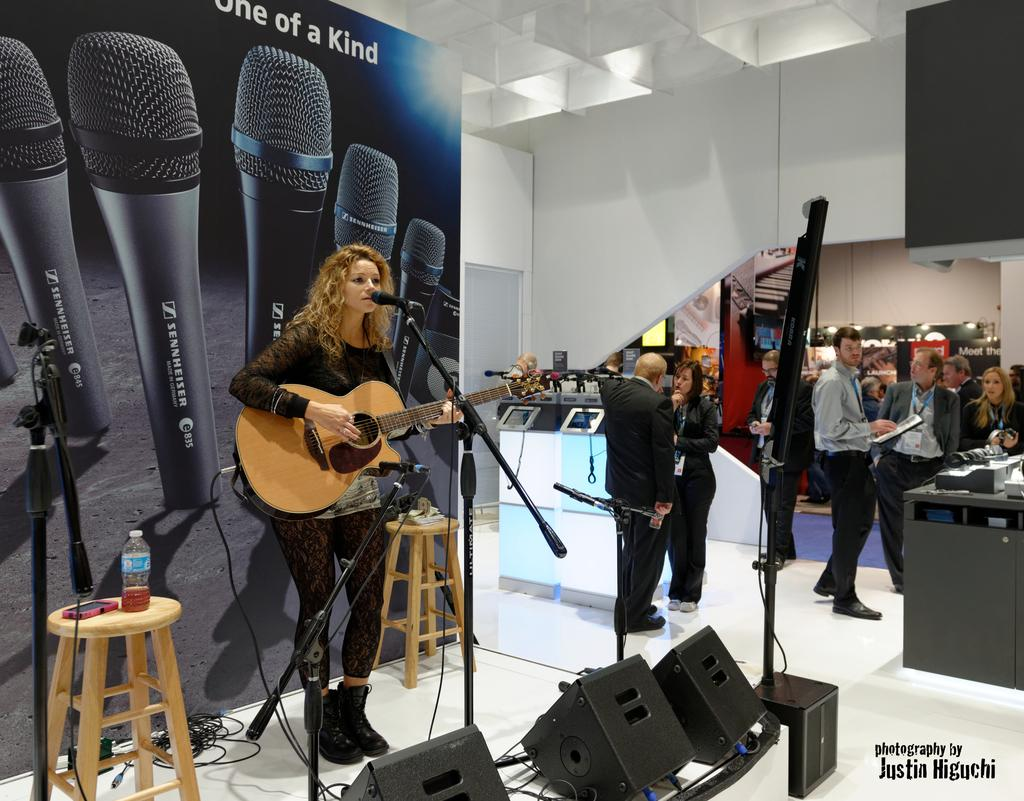How many people are in the room where the image was taken? There are many people in the room. What is the girl doing in the image? The girl is playing the guitar and singing a song. Where is the girl performing? She is performing on a stage. What can be seen on the stage besides the girl? There are musical instruments present on the stage. What type of hose is being used to water the orange tree in the image? There is no hose or orange tree present in the image. 